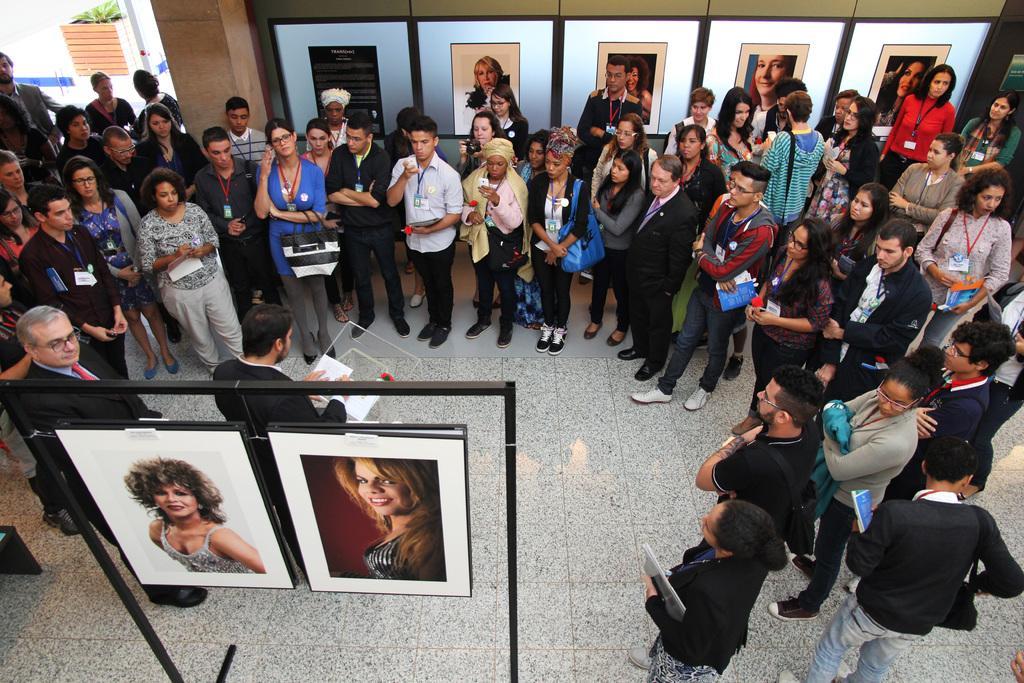Describe this image in one or two sentences. There is a person wearing black suit is standing and holding a paper in his hands and there are two photo frames behind him and there are few people standing in front of him. 